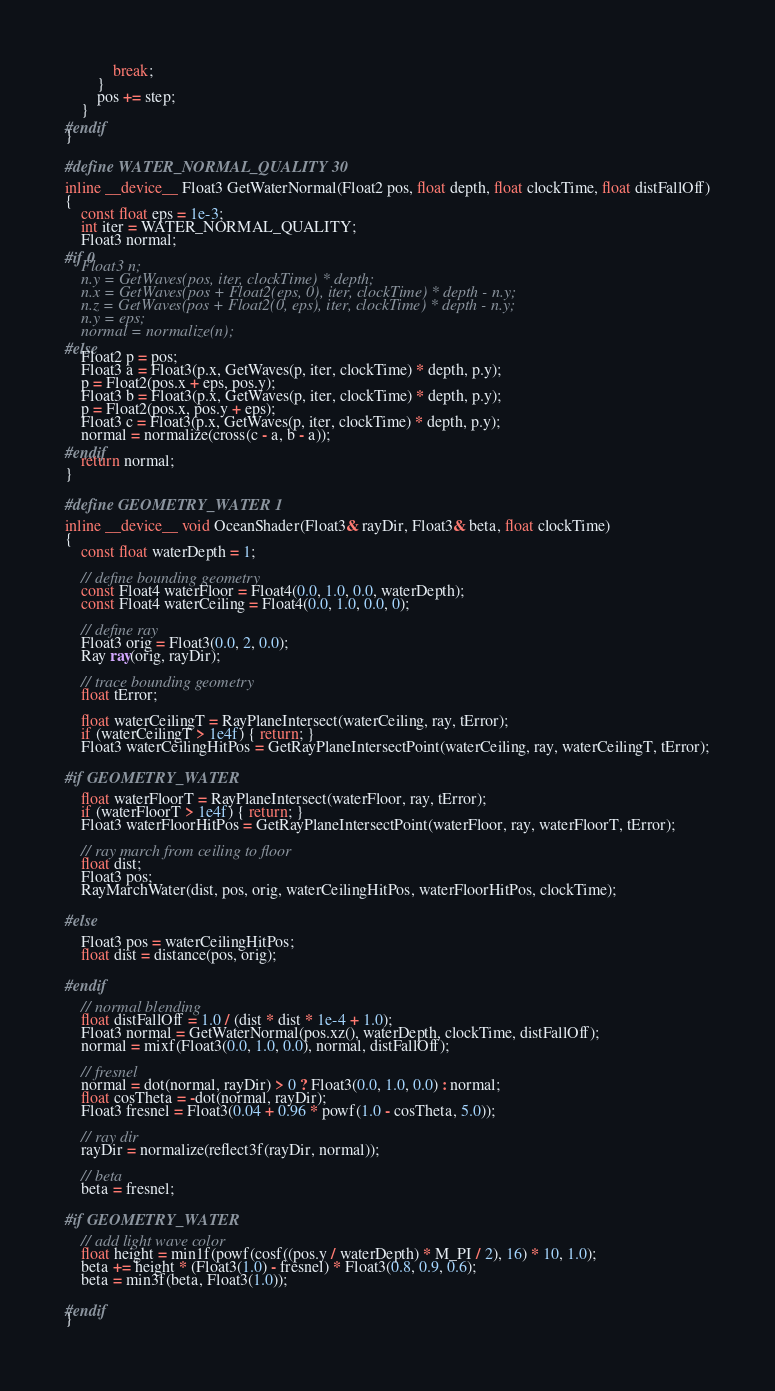Convert code to text. <code><loc_0><loc_0><loc_500><loc_500><_Cuda_>			break;
		}
		pos += step;
	}
#endif
}

#define WATER_NORMAL_QUALITY 30

inline __device__ Float3 GetWaterNormal(Float2 pos, float depth, float clockTime, float distFallOff)
{
	const float eps = 1e-3;
	int iter = WATER_NORMAL_QUALITY;
	Float3 normal;
#if 0
	Float3 n;
    n.y = GetWaves(pos, iter, clockTime) * depth;
    n.x = GetWaves(pos + Float2(eps, 0), iter, clockTime) * depth - n.y;
    n.z = GetWaves(pos + Float2(0, eps), iter, clockTime) * depth - n.y;
    n.y = eps;
	normal = normalize(n);
#else
	Float2 p = pos;
	Float3 a = Float3(p.x, GetWaves(p, iter, clockTime) * depth, p.y);
	p = Float2(pos.x + eps, pos.y);
	Float3 b = Float3(p.x, GetWaves(p, iter, clockTime) * depth, p.y);
	p = Float2(pos.x, pos.y + eps);
	Float3 c = Float3(p.x, GetWaves(p, iter, clockTime) * depth, p.y);
	normal = normalize(cross(c - a, b - a));
#endif
	return normal;
}

#define GEOMETRY_WATER 1

inline __device__ void OceanShader(Float3& rayDir, Float3& beta, float clockTime)
{
	const float waterDepth = 1;

	// define bounding geometry
	const Float4 waterFloor = Float4(0.0, 1.0, 0.0, waterDepth);
	const Float4 waterCeiling = Float4(0.0, 1.0, 0.0, 0);

	// define ray
	Float3 orig = Float3(0.0, 2, 0.0);
	Ray ray(orig, rayDir);

	// trace bounding geometry
	float tError;

	float waterCeilingT = RayPlaneIntersect(waterCeiling, ray, tError);
	if (waterCeilingT > 1e4f) { return; }
	Float3 waterCeilingHitPos = GetRayPlaneIntersectPoint(waterCeiling, ray, waterCeilingT, tError);

#if GEOMETRY_WATER

	float waterFloorT = RayPlaneIntersect(waterFloor, ray, tError);
	if (waterFloorT > 1e4f) { return; }
	Float3 waterFloorHitPos = GetRayPlaneIntersectPoint(waterFloor, ray, waterFloorT, tError);

	// ray march from ceiling to floor
	float dist;
	Float3 pos;
	RayMarchWater(dist, pos, orig, waterCeilingHitPos, waterFloorHitPos, clockTime);

#else

	Float3 pos = waterCeilingHitPos;
	float dist = distance(pos, orig);

#endif

	// normal blending
	float distFallOff = 1.0 / (dist * dist * 1e-4 + 1.0);
	Float3 normal = GetWaterNormal(pos.xz(), waterDepth, clockTime, distFallOff);
	normal = mixf(Float3(0.0, 1.0, 0.0), normal, distFallOff);

	// fresnel
	normal = dot(normal, rayDir) > 0 ? Float3(0.0, 1.0, 0.0) : normal;
	float cosTheta = -dot(normal, rayDir);
	Float3 fresnel = Float3(0.04 + 0.96 * powf(1.0 - cosTheta, 5.0));

	// ray dir
	rayDir = normalize(reflect3f(rayDir, normal));

	// beta
	beta = fresnel;

#if GEOMETRY_WATER

	// add light wave color
	float height = min1f(powf(cosf((pos.y / waterDepth) * M_PI / 2), 16) * 10, 1.0);
	beta += height * (Float3(1.0) - fresnel) * Float3(0.8, 0.9, 0.6);
	beta = min3f(beta, Float3(1.0));

#endif
}
</code> 